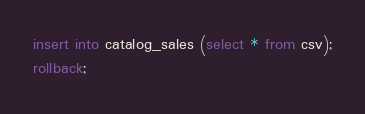Convert code to text. <code><loc_0><loc_0><loc_500><loc_500><_SQL_>insert into catalog_sales (select * from csv);
rollback;

</code> 